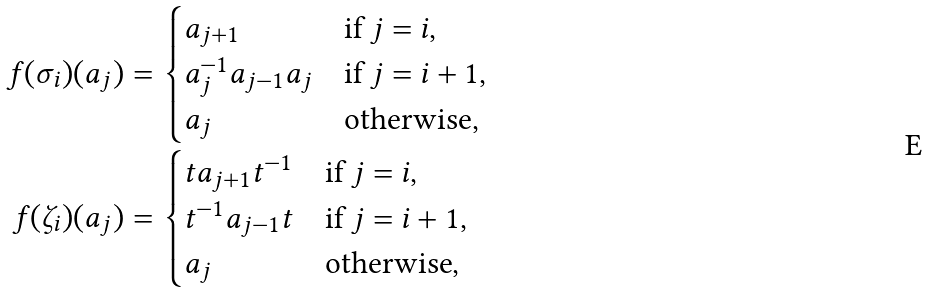Convert formula to latex. <formula><loc_0><loc_0><loc_500><loc_500>f ( \sigma _ { i } ) ( a _ { j } ) & = \begin{cases} a _ { j + 1 } & \text {if $j=i$,} \\ a _ { j } ^ { - 1 } a _ { j - 1 } a _ { j } & \text {if $j=i+1$,} \\ a _ { j } & \text {otherwise} , \end{cases} \\ f ( \zeta _ { i } ) ( a _ { j } ) & = \begin{cases} t a _ { j + 1 } t ^ { - 1 } & \text {if $j=i$,} \\ t ^ { - 1 } a _ { j - 1 } t & \text {if $j=i+1$,} \\ a _ { j } & \text {otherwise} , \\ \end{cases}</formula> 